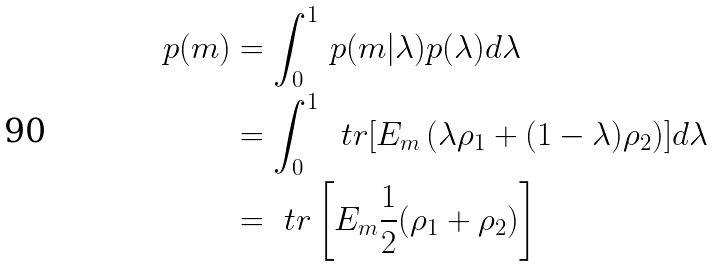<formula> <loc_0><loc_0><loc_500><loc_500>p ( m ) & = \int _ { 0 } ^ { 1 } \, p ( m | \lambda ) p ( \lambda ) d \lambda \\ & = \int _ { 0 } ^ { 1 } \, \ t r [ E _ { m } \left ( \lambda \rho _ { 1 } + ( 1 - \lambda ) \rho _ { 2 } \right ) ] d \lambda \\ & = \ t r \left [ E _ { m } \frac { 1 } { 2 } ( \rho _ { 1 } + \rho _ { 2 } ) \right ]</formula> 